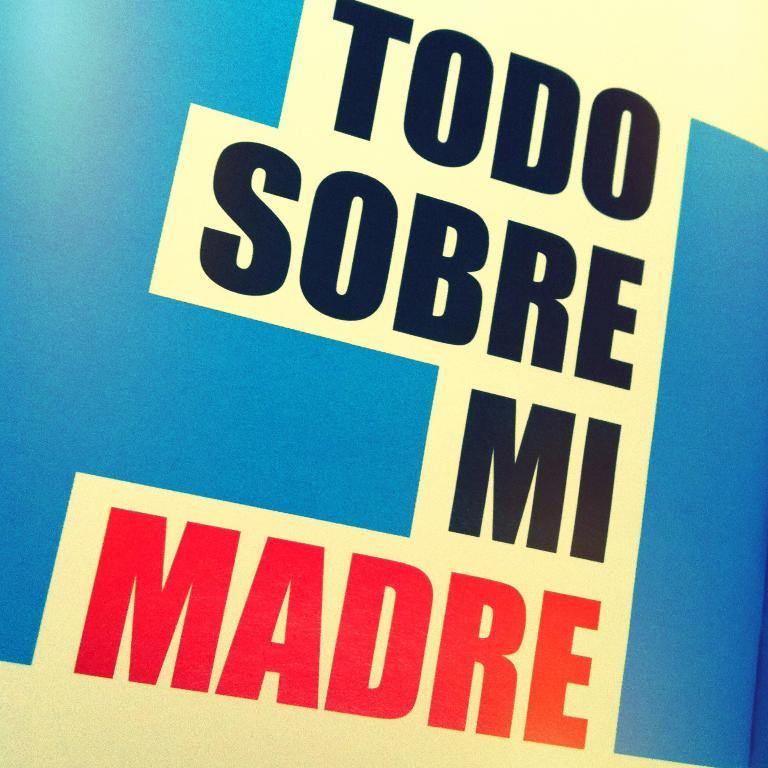Provide a one-sentence caption for the provided image. Poster that says Todo Sobre Mi Madre in spanish. 